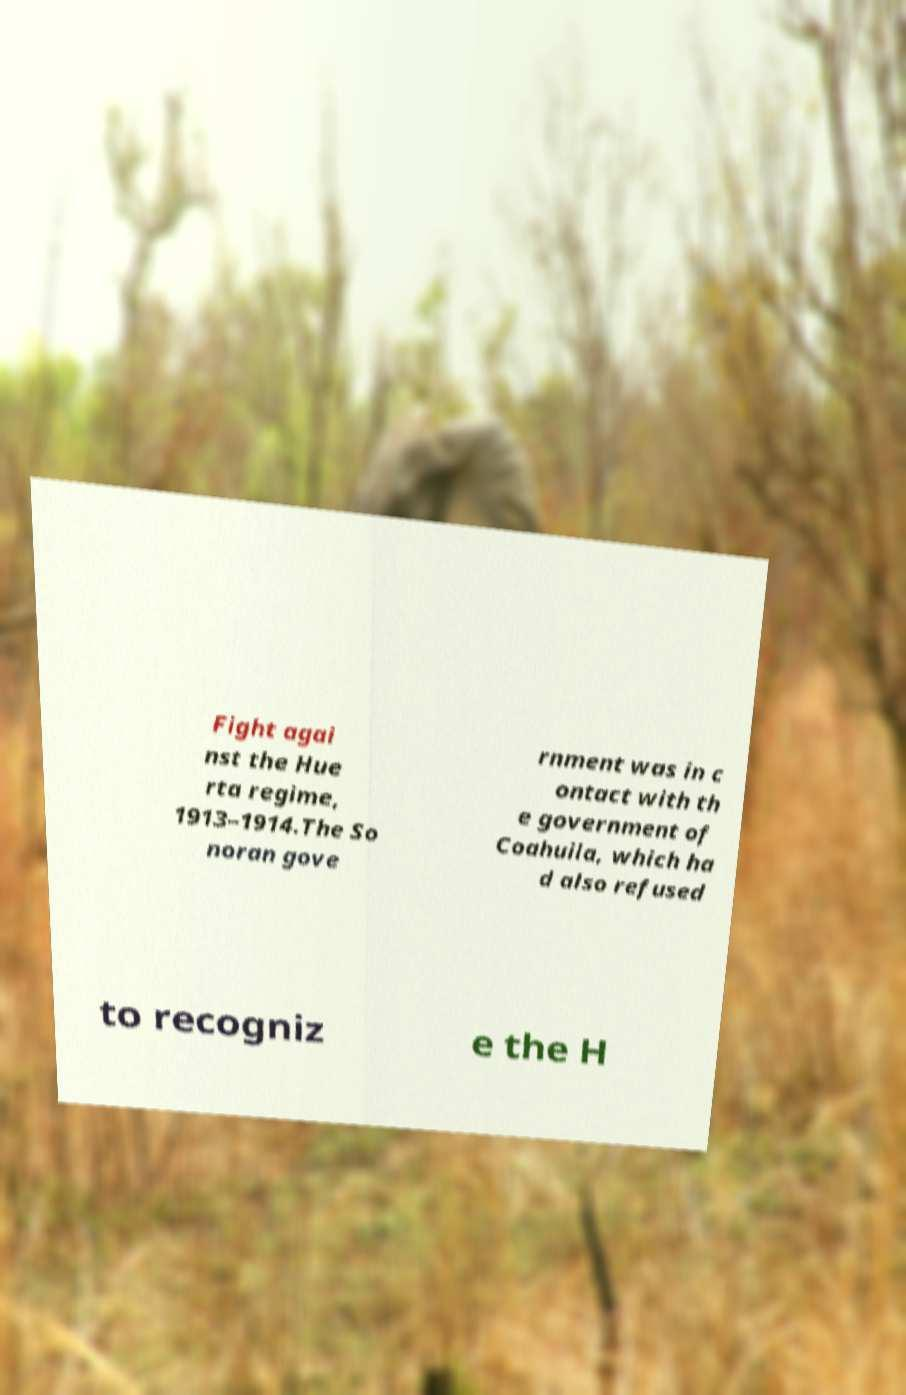Could you extract and type out the text from this image? Fight agai nst the Hue rta regime, 1913–1914.The So noran gove rnment was in c ontact with th e government of Coahuila, which ha d also refused to recogniz e the H 